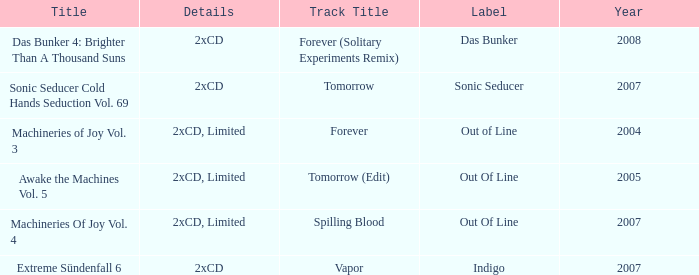Which label has a year older than 2004 and a 2xcd detail as well as the sonic seducer cold hands seduction vol. 69 title? Sonic Seducer. 